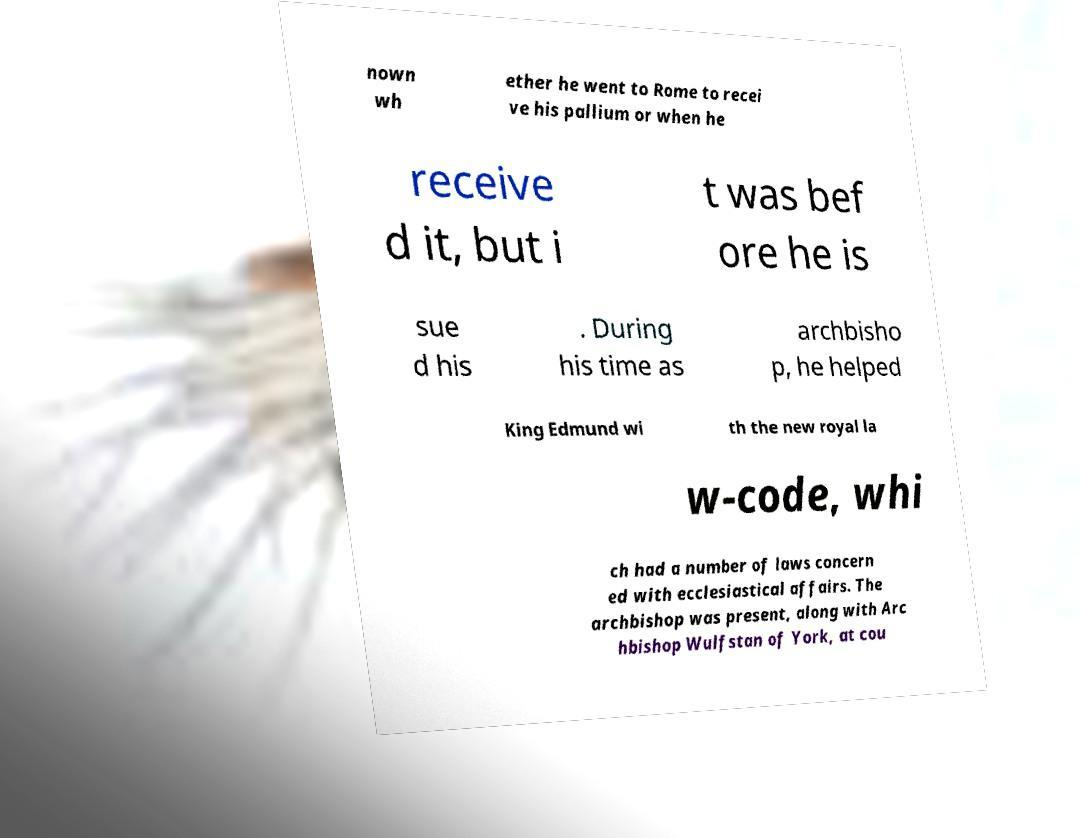Could you assist in decoding the text presented in this image and type it out clearly? nown wh ether he went to Rome to recei ve his pallium or when he receive d it, but i t was bef ore he is sue d his . During his time as archbisho p, he helped King Edmund wi th the new royal la w-code, whi ch had a number of laws concern ed with ecclesiastical affairs. The archbishop was present, along with Arc hbishop Wulfstan of York, at cou 